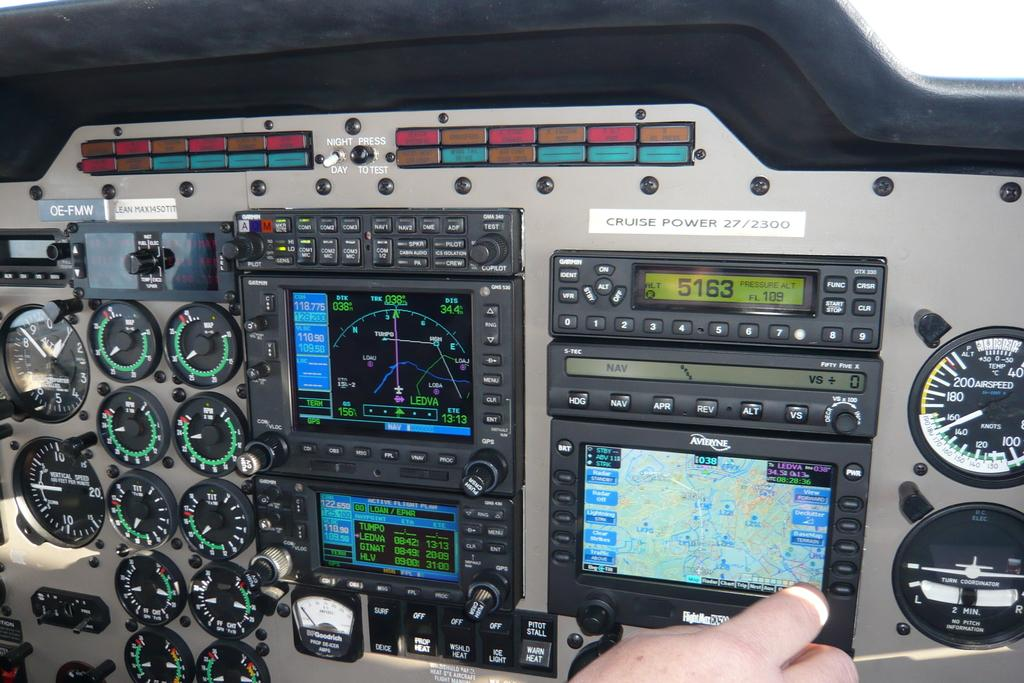What is the main subject of the image? The main subject of the image is a cockpit. Can you describe any visible body parts in the image? Yes, there is a person's hand visible at the bottom of the image. What color is the paint on the sail in the image? There is no sail or paint present in the image; it features a cockpit and a person's hand. What is the person in the image doing with their mouth? There is no visible mouth in the image; only a person's hand is visible. 